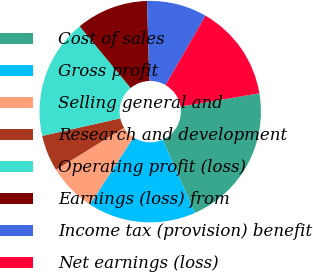Convert chart. <chart><loc_0><loc_0><loc_500><loc_500><pie_chart><fcel>Cost of sales<fcel>Gross profit<fcel>Selling general and<fcel>Research and development<fcel>Operating profit (loss)<fcel>Earnings (loss) from<fcel>Income tax (provision) benefit<fcel>Net earnings (loss)<nl><fcel>21.04%<fcel>15.78%<fcel>7.03%<fcel>5.28%<fcel>17.53%<fcel>10.53%<fcel>8.78%<fcel>14.03%<nl></chart> 